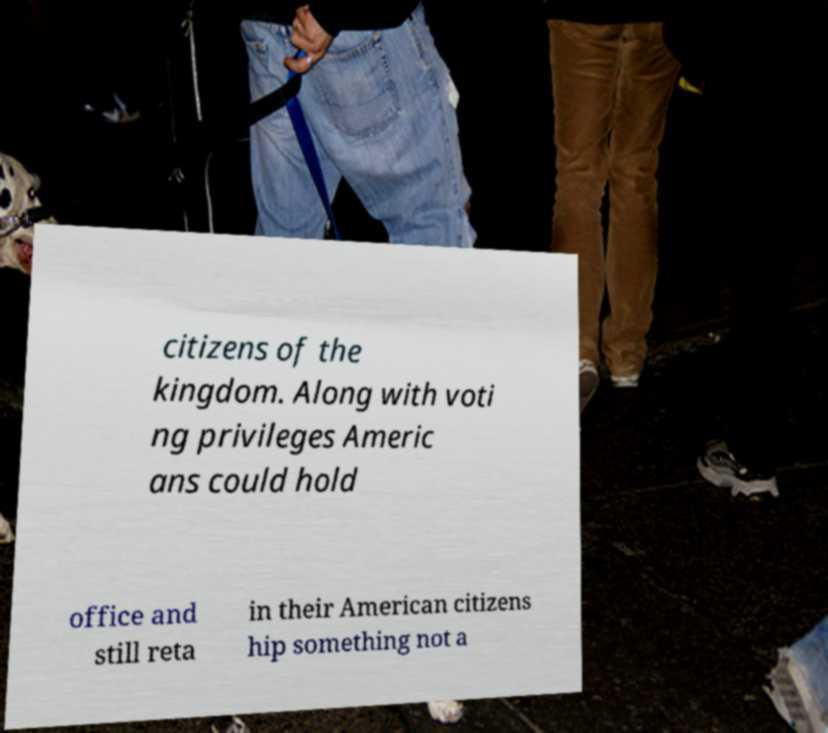Could you extract and type out the text from this image? citizens of the kingdom. Along with voti ng privileges Americ ans could hold office and still reta in their American citizens hip something not a 